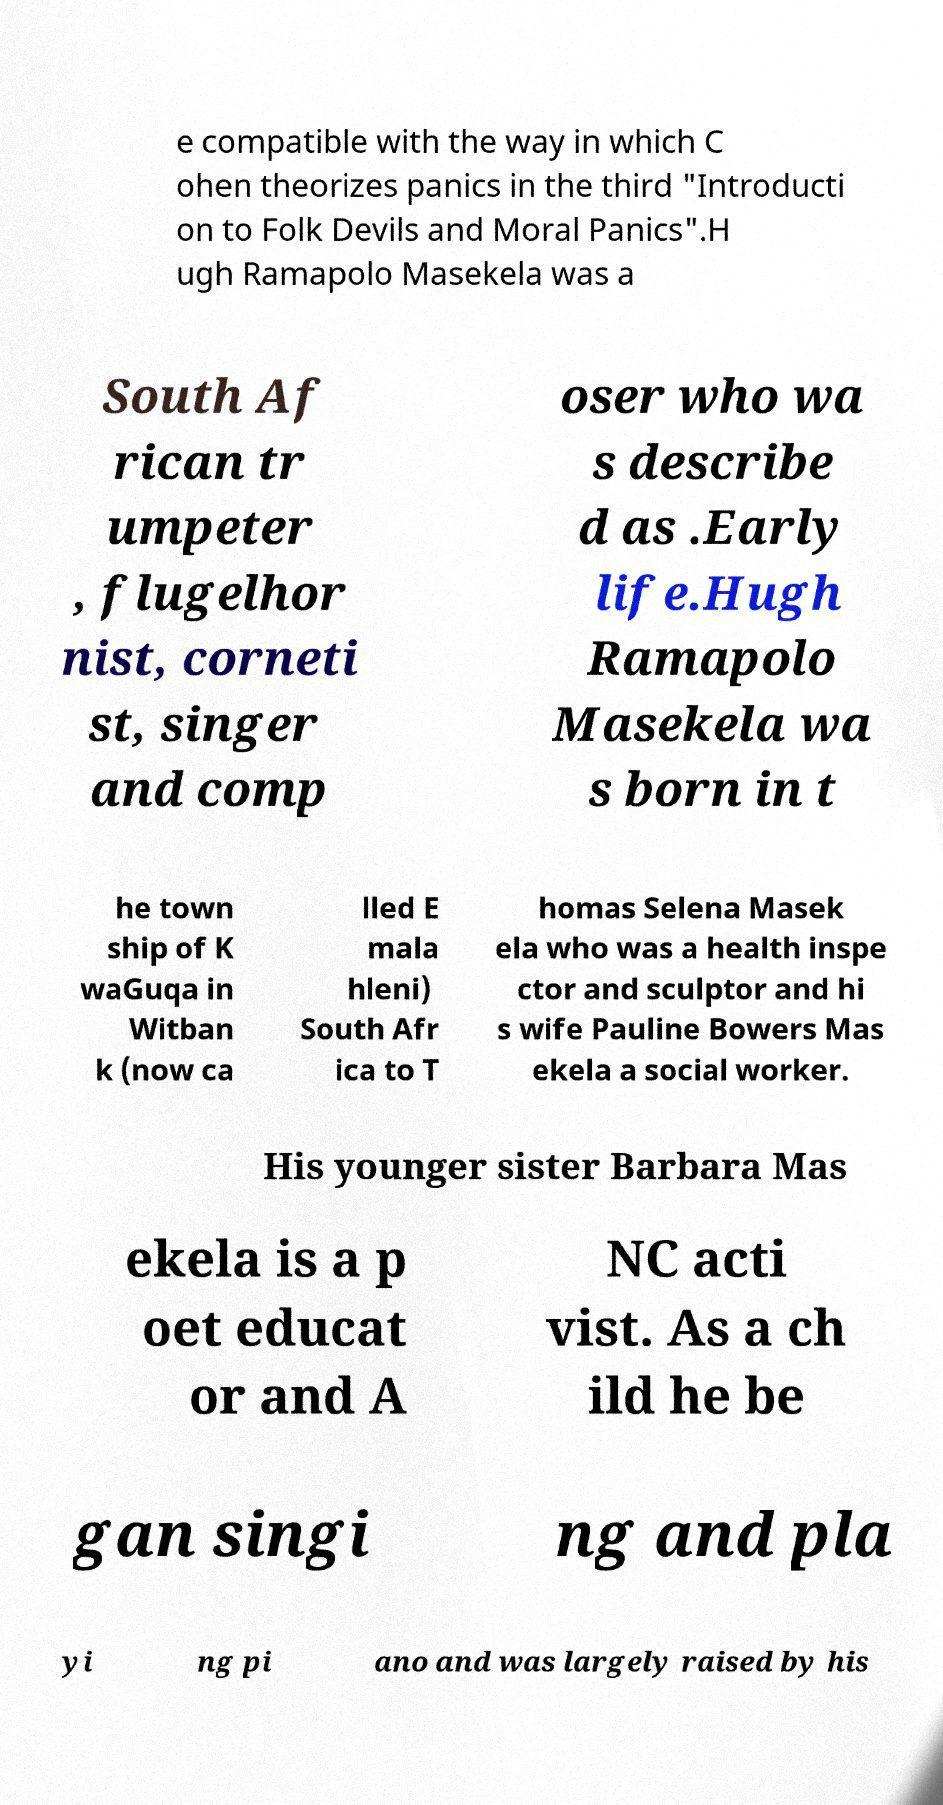There's text embedded in this image that I need extracted. Can you transcribe it verbatim? e compatible with the way in which C ohen theorizes panics in the third "Introducti on to Folk Devils and Moral Panics".H ugh Ramapolo Masekela was a South Af rican tr umpeter , flugelhor nist, corneti st, singer and comp oser who wa s describe d as .Early life.Hugh Ramapolo Masekela wa s born in t he town ship of K waGuqa in Witban k (now ca lled E mala hleni) South Afr ica to T homas Selena Masek ela who was a health inspe ctor and sculptor and hi s wife Pauline Bowers Mas ekela a social worker. His younger sister Barbara Mas ekela is a p oet educat or and A NC acti vist. As a ch ild he be gan singi ng and pla yi ng pi ano and was largely raised by his 